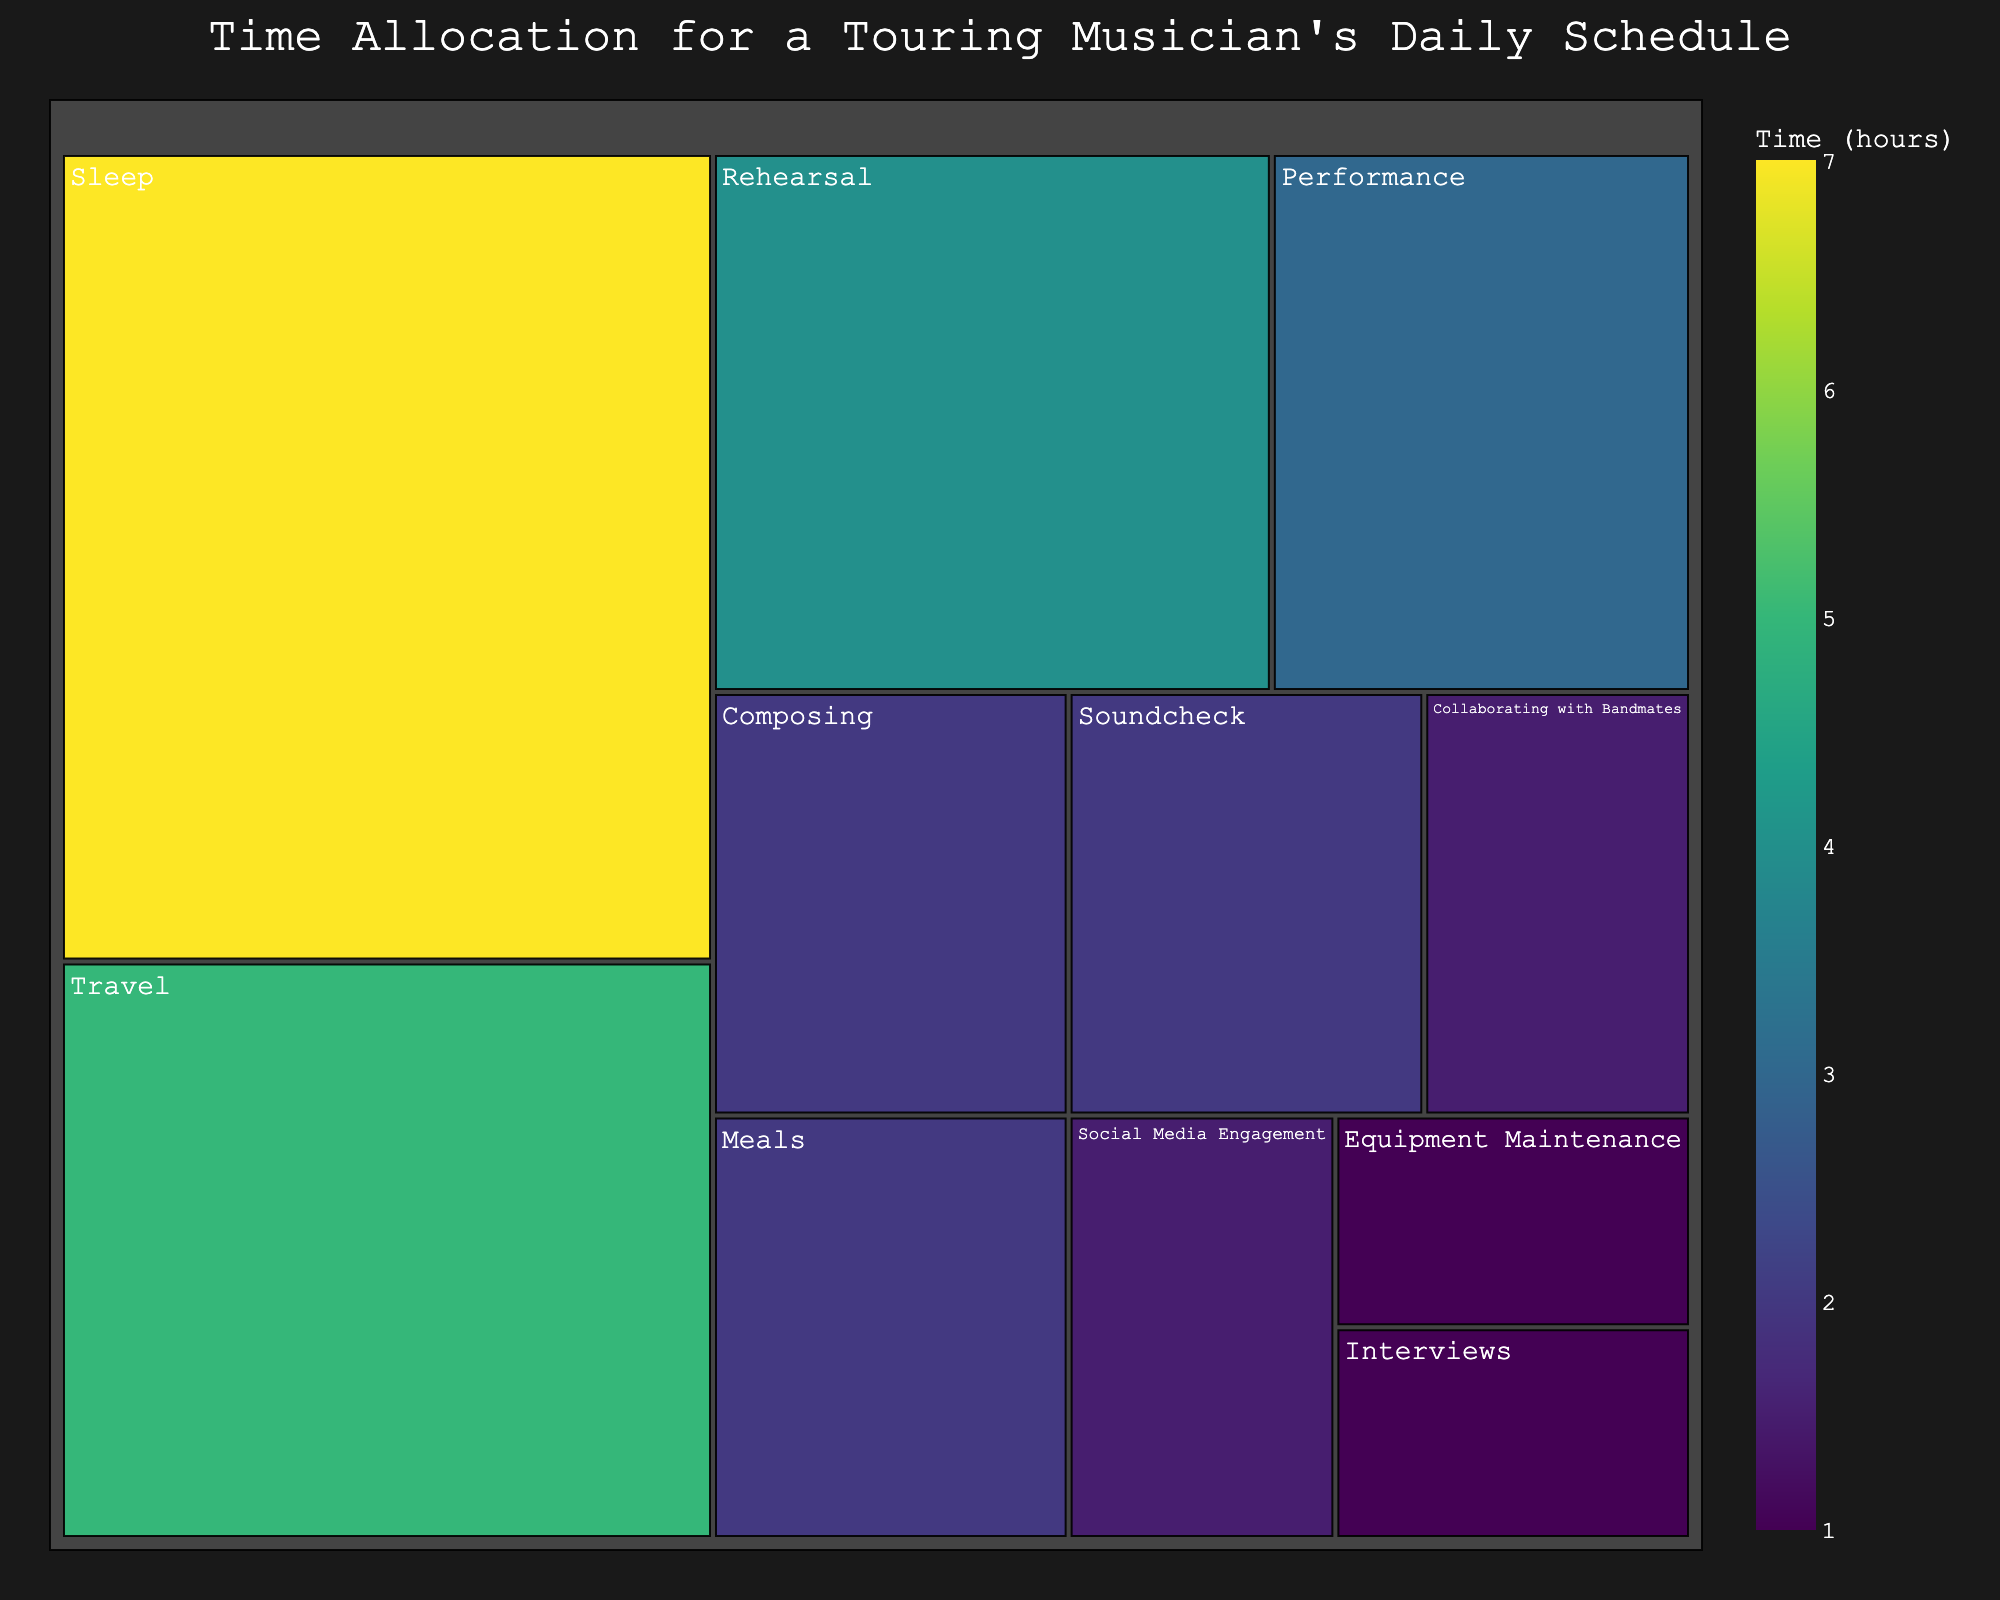What's the title of the treemap? The title of the treemap is placed at the top and is visually prominent. It reads "Time Allocation for a Touring Musician's Daily Schedule".
Answer: Time Allocation for a Touring Musician's Daily Schedule How many hours are spent on performance each day? The treemap shows an individual box labeled "Performance" with a corresponding value. This value indicates the number of hours spent on performance daily.
Answer: 3 Which activity takes up the most time in a day? The size of the boxes in a treemap corresponds to the time spent on each activity. The largest box indicates the activity that takes up the most time.
Answer: Travel How much time is spent daily on activities that involve musical work (Performance, Rehearsal, Composing, Soundcheck)? Sum the hours of the activities related to musical work. Performance (3) + Rehearsal (4) + Composing (2) + Soundcheck (2).
Answer: 11 Compare the time spent on Social Media Engagement and Interviews. Which one is more and by how much? The boxes representing Social Media Engagement and Interviews can be compared by their values. Social Media Engagement (1.5) – Interviews (1).
Answer: Social Media Engagement by 0.5 hours What percentage of the day is spent sleeping? The total number of hours in a day is 24. The box labeled "Sleep" indicates the hours. Calculate (Sleep / 24) * 100.
Answer: 29.17% By how many hours does the time spent on sleeping exceed the time spent on travel? Compare the boxes for Sleep and Travel. Sleep (7) – Travel (5).
Answer: 2 Is more time spent on equipment maintenance or collaborating with bandmates? Check the values in the boxes for Equipment Maintenance and Collaborating with Bandmates.
Answer: Collaborating with Bandmates What's the combined time spent on Meals and Sleep? Sum the hours for Meals and Sleep. Meals (2) + Sleep (7).
Answer: 9 How does the time spent on composing compare to that of soundcheck? Compare the values in the boxes for Composing and Soundcheck, which both indicate 2 hours.
Answer: Equal 